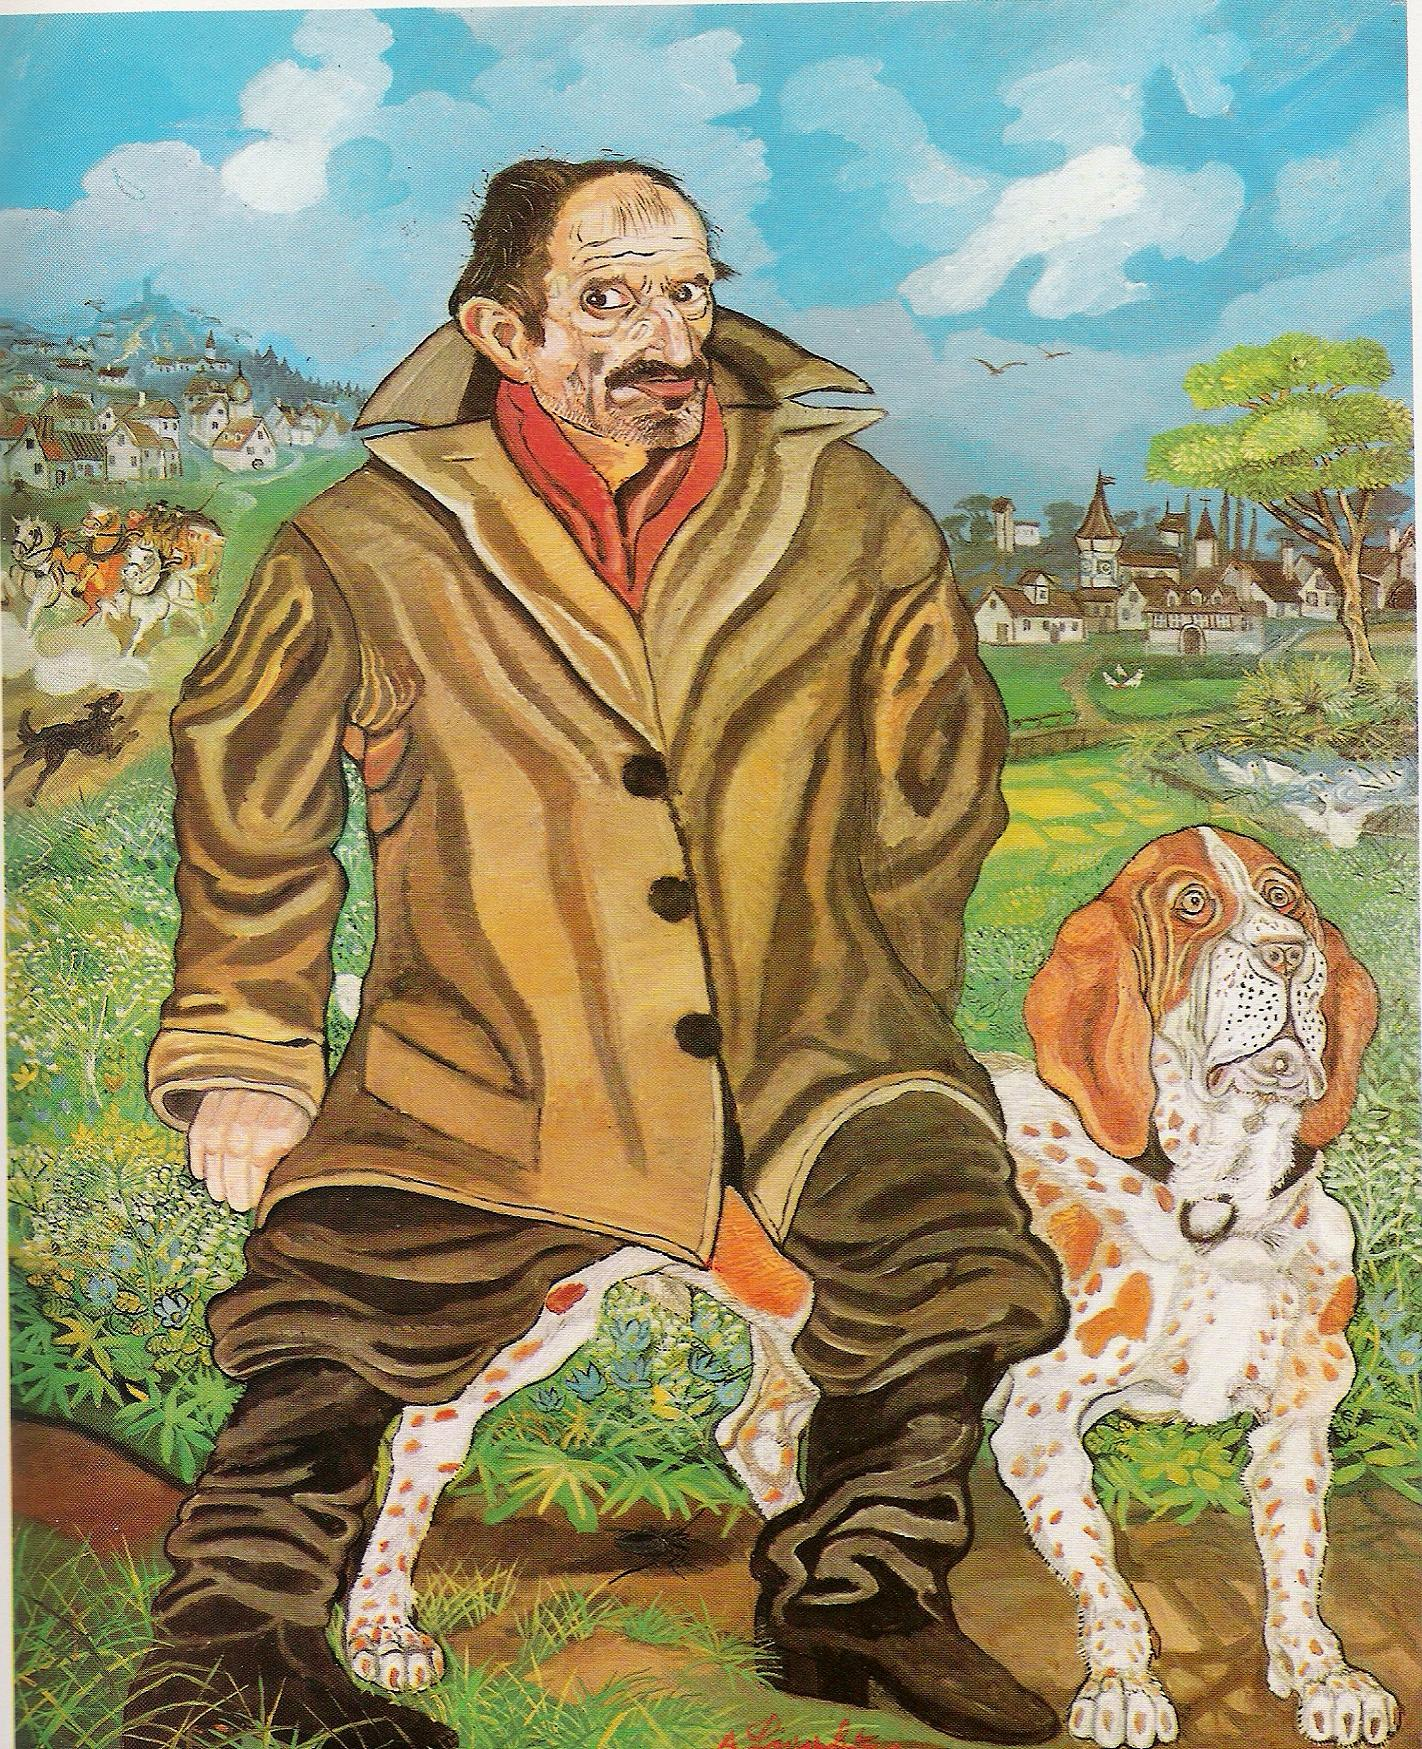Imagine if the man and dog were part of a fantasy story. What would that story be? In a fantasy story, the man might be an aged wizard named Eldric, with his loyal dog, Bardo. Eldric, known for his deep wisdom and powerful sorcery, is on a quest to reclaim his enchanted staff stolen by a malevolent sorcerer. Bardo, not just an ordinary dog, possesses an uncanny ability to sense magic and danger. Their journey takes them through the vibrant, surreal landscapes where they encounter mythical creatures, form alliances with enchanted beings, and unravel centuries-old prophecies. As they traverse through enchanted forests, perilous mountains, and the quaint village, each step brings them closer to a climactic showdown at the castle on the distant hill, where the fate of their world hang in balance. The colorful, dreamlike surroundings serve both as a beautiful backdrop and a treacherous labyrinth that tests the strength of their bond and the limits of their courage. Could you provide a short poem about the man's journey in this whimsical world? Through lands of dreams and colors bright,
Eldric and Bardo stride with might.
From village paths to castle's door,
They seek the staff of legends' lore.
With every step, the magic grows,
In fields where the wild river flows.
Together bound, the wise and bold,
Their epic tale shall be retold. Let's dive deeper into what makes the surreal art style so appealing. What about its elements draw viewers in? Surrealism captivates because it transcends everyday realities and taps into the subconscious mind, where dreams, instinct, and imagination reign supreme. The blend of incongruous elements—like a man with a large nose and mustache in an oversized coat alongside a peculiarly expressive dog—creates a sense of mystery and curiosity. These unexpected juxtapositions challenge logical interpretations, encouraging viewers to explore the hidden meanings and stories behind the imagery. The vibrant and sometimes surreal use of color amplifies emotions and underscores the dreamlike quality, making the scene pop with life and whimsy. This combination of ordinary and extraordinary, familiar and fantastic, invites viewers to pause and delve deeper, making surreal art not just a viewing experience but an ongoing adventure into the unknown realms of the mind. 